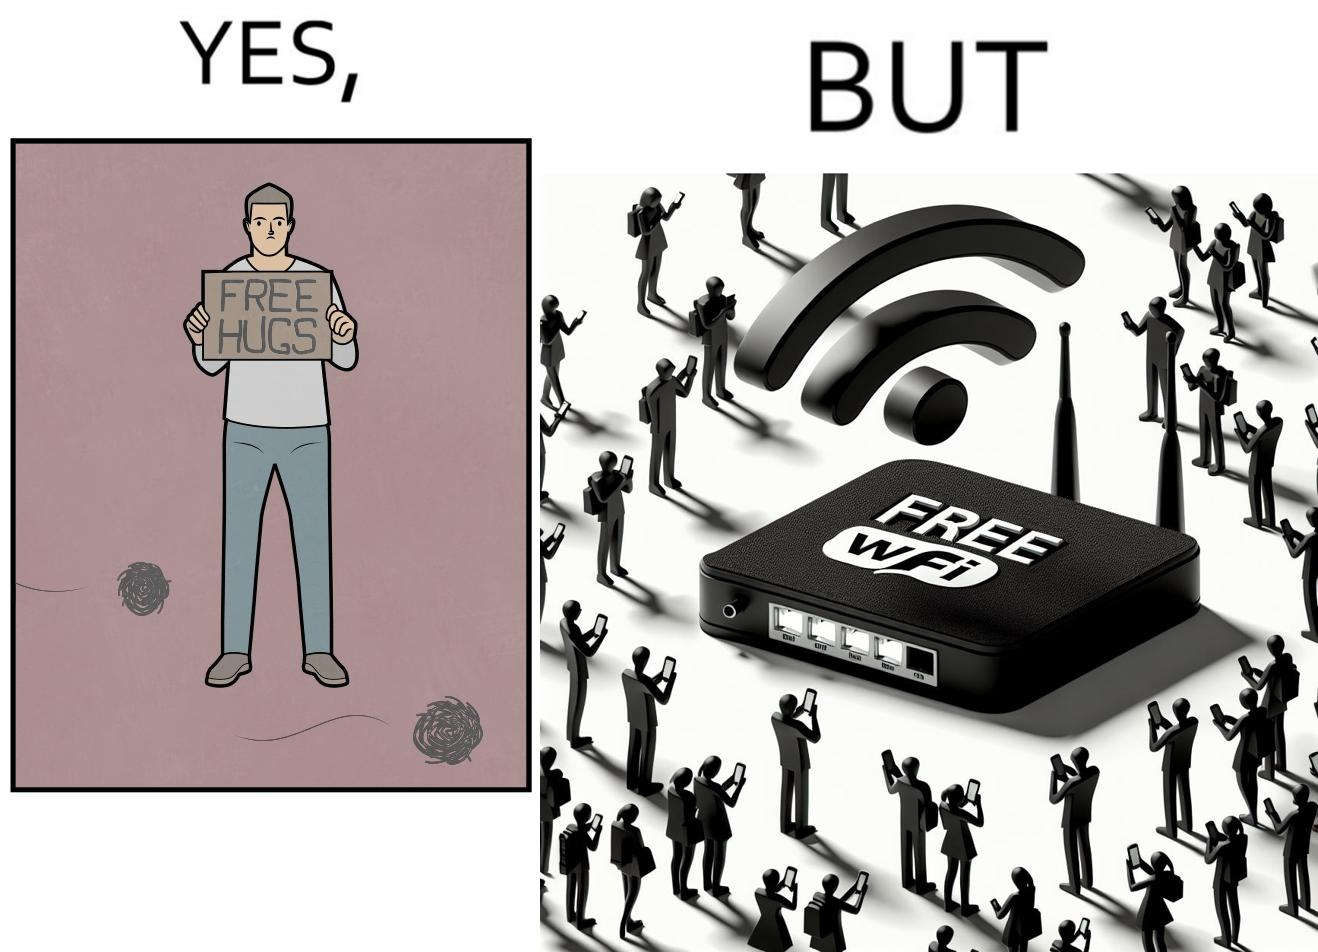Provide a description of this image. This image is ironical, as a person holding up a "Free Hugs" sign is standing alone, while an inanimate Wi-fi Router giving "Free Wifi" is surrounded people trying to connect to it. This shows a growing lack of empathy in our society, while showing our increasing dependence on the digital devices in a virtual world. 